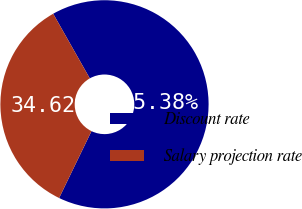<chart> <loc_0><loc_0><loc_500><loc_500><pie_chart><fcel>Discount rate<fcel>Salary projection rate<nl><fcel>65.38%<fcel>34.62%<nl></chart> 